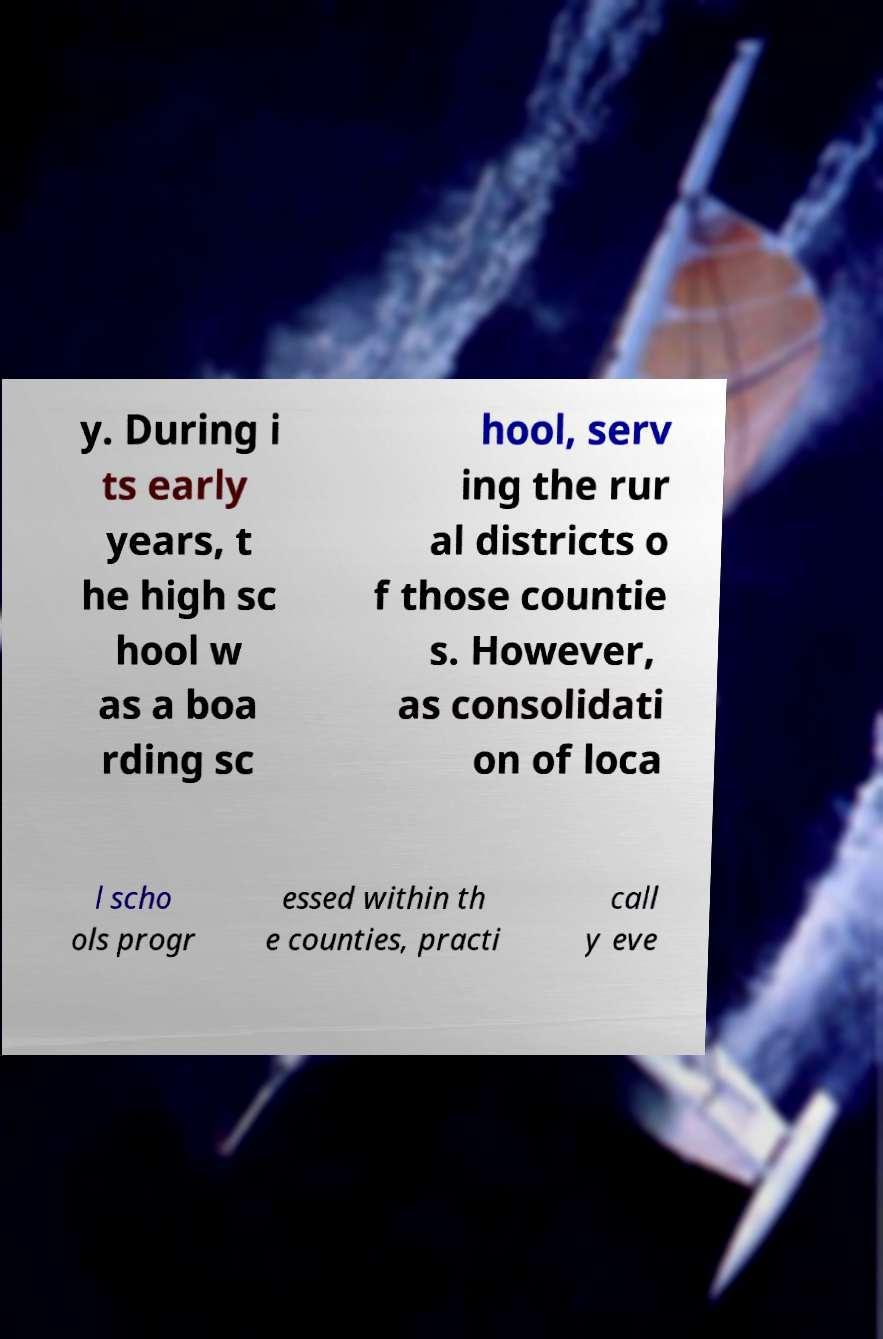I need the written content from this picture converted into text. Can you do that? y. During i ts early years, t he high sc hool w as a boa rding sc hool, serv ing the rur al districts o f those countie s. However, as consolidati on of loca l scho ols progr essed within th e counties, practi call y eve 